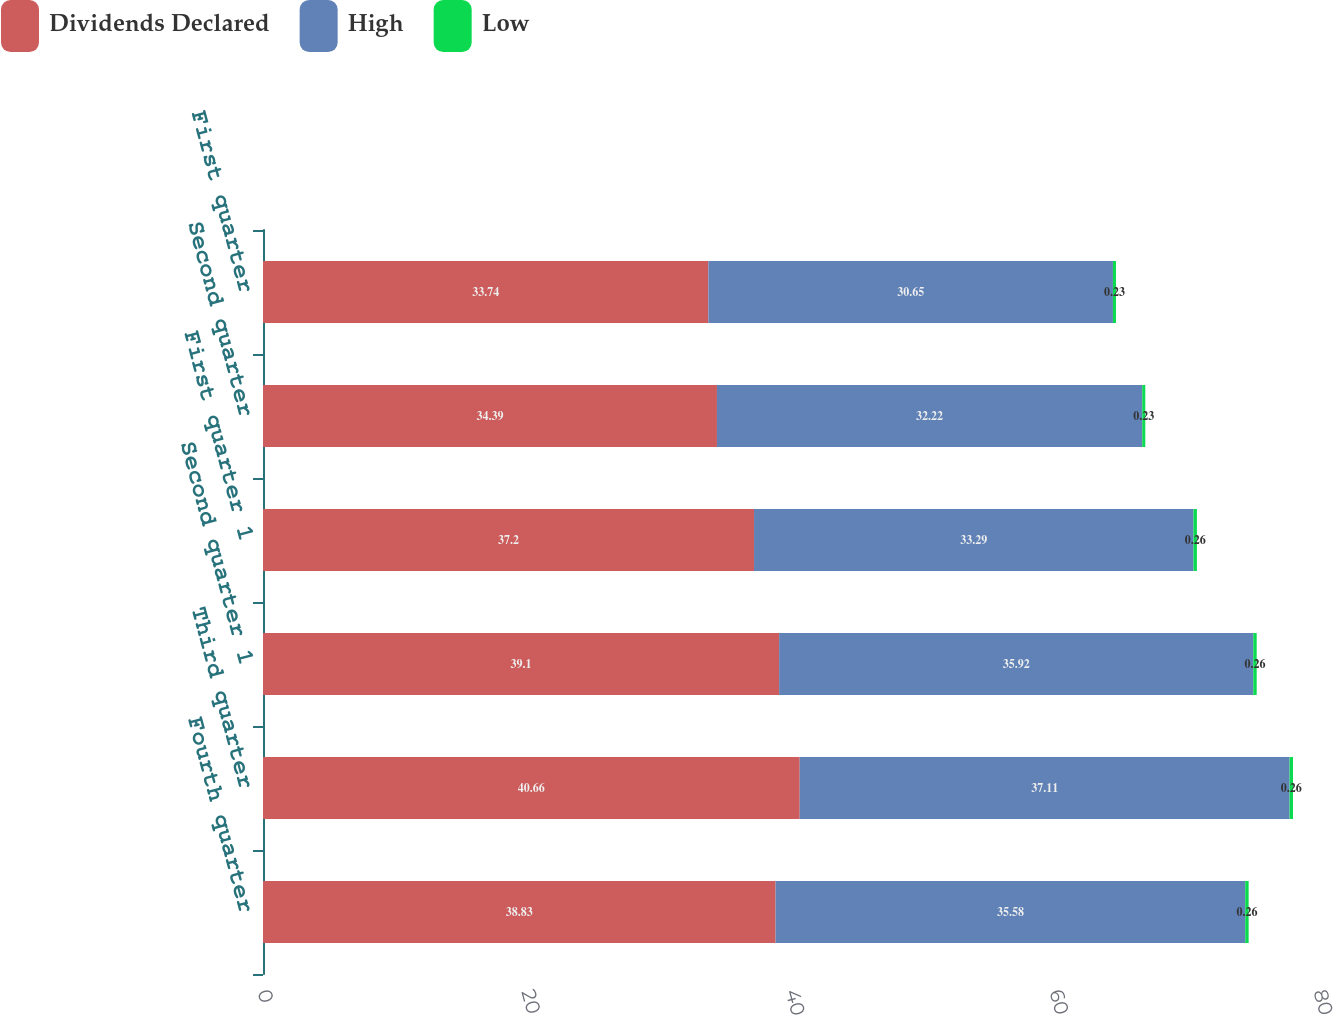<chart> <loc_0><loc_0><loc_500><loc_500><stacked_bar_chart><ecel><fcel>Fourth quarter<fcel>Third quarter<fcel>Second quarter 1<fcel>First quarter 1<fcel>Second quarter<fcel>First quarter<nl><fcel>Dividends Declared<fcel>38.83<fcel>40.66<fcel>39.1<fcel>37.2<fcel>34.39<fcel>33.74<nl><fcel>High<fcel>35.58<fcel>37.11<fcel>35.92<fcel>33.29<fcel>32.22<fcel>30.65<nl><fcel>Low<fcel>0.26<fcel>0.26<fcel>0.26<fcel>0.26<fcel>0.23<fcel>0.23<nl></chart> 